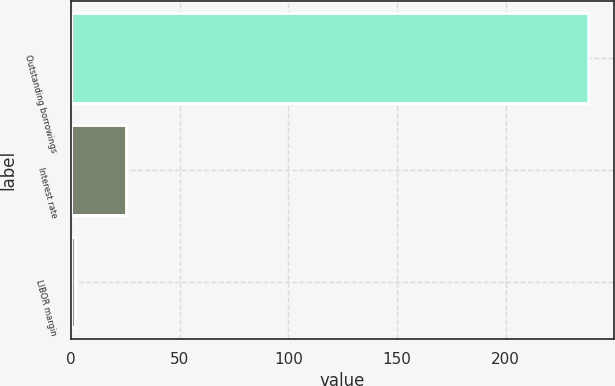Convert chart to OTSL. <chart><loc_0><loc_0><loc_500><loc_500><bar_chart><fcel>Outstanding borrowings<fcel>Interest rate<fcel>LIBOR margin<nl><fcel>237.9<fcel>25.37<fcel>1.75<nl></chart> 